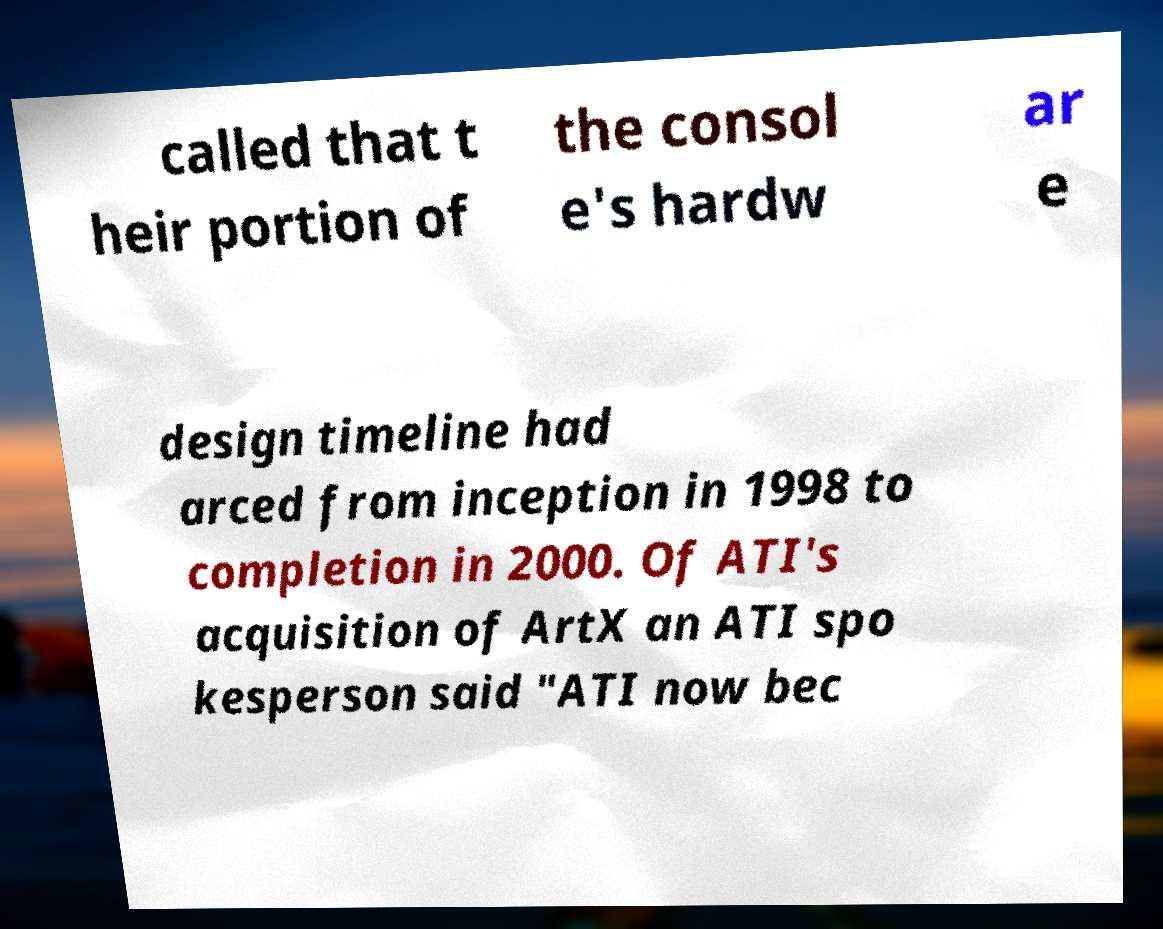Can you read and provide the text displayed in the image?This photo seems to have some interesting text. Can you extract and type it out for me? called that t heir portion of the consol e's hardw ar e design timeline had arced from inception in 1998 to completion in 2000. Of ATI's acquisition of ArtX an ATI spo kesperson said "ATI now bec 